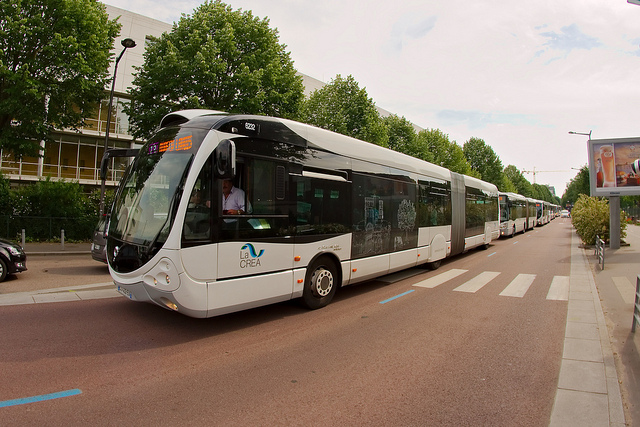Identify the text contained in this image. CREA La 